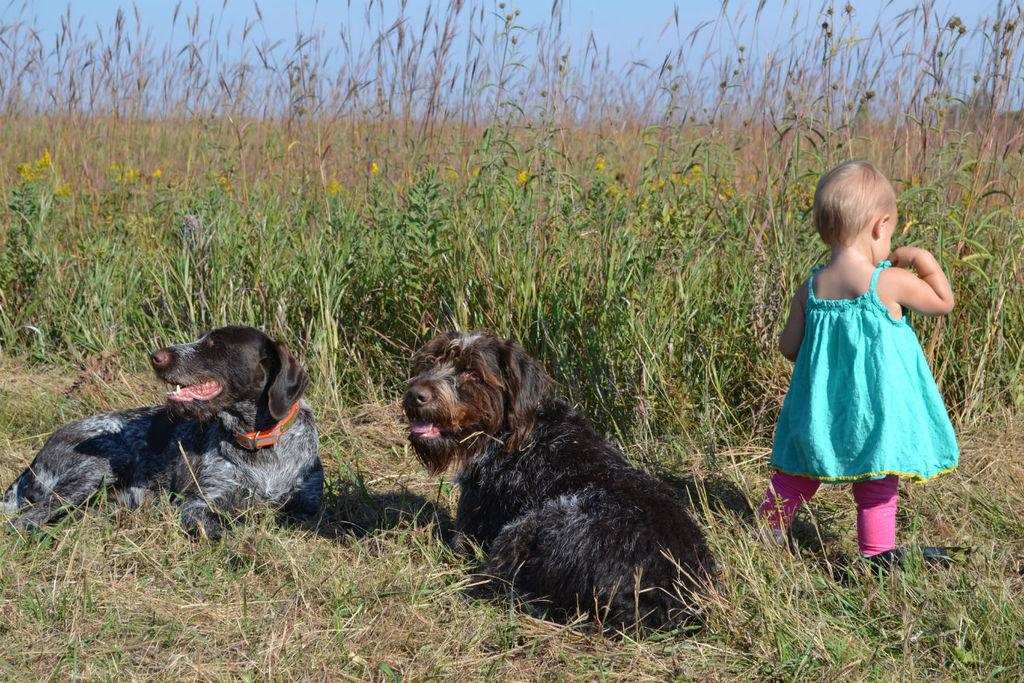What animals are sitting on the grass in the image? There are dogs sitting on the grass in the image. What is the girl doing on the right side of the image? The girl is standing on the right side of the image. What can be seen in the background of the image? There is a field and the sky visible in the background of the image. What type of shirt is the farmer wearing in the image? There is no farmer present in the image, so it is not possible to determine what type of shirt they might be wearing. 